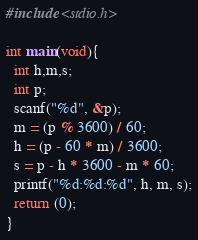<code> <loc_0><loc_0><loc_500><loc_500><_C_>#include <stdio.h>

int main(void){
  int h,m,s;
  int p;
  scanf("%d", &p);
  m = (p % 3600) / 60;
  h = (p - 60 * m) / 3600;
  s = p - h * 3600 - m * 60;
  printf("%d:%d:%d", h, m, s);
  return (0);
}</code> 